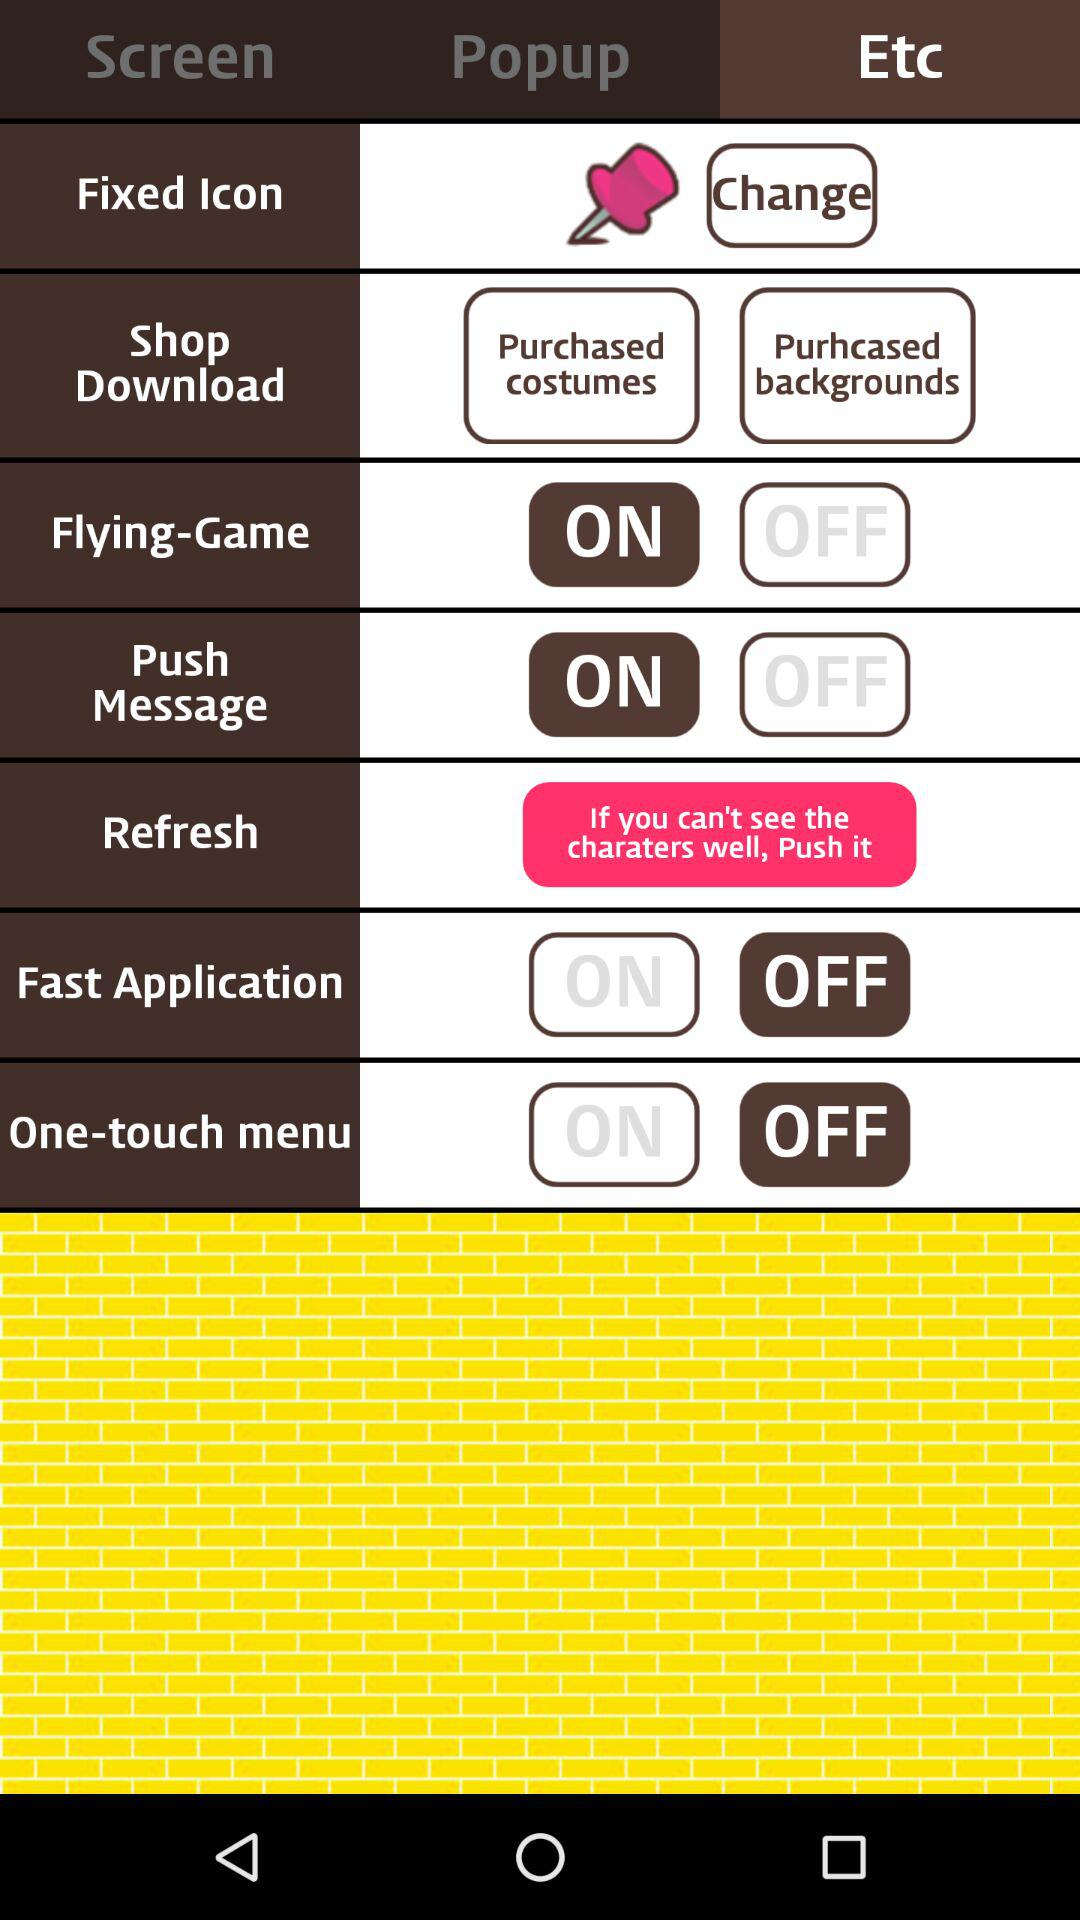What is the status of "Flying-Game"? The status of "Flying-Game" is "on". 